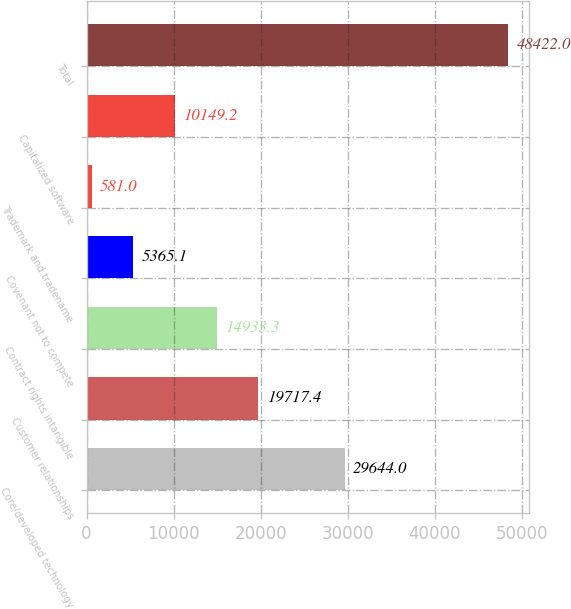Convert chart. <chart><loc_0><loc_0><loc_500><loc_500><bar_chart><fcel>Core/developed technology<fcel>Customer relationships<fcel>Contract rights intangible<fcel>Covenant not to compete<fcel>Trademark and tradename<fcel>Capitalized software<fcel>Total<nl><fcel>29644<fcel>19717.4<fcel>14933.3<fcel>5365.1<fcel>581<fcel>10149.2<fcel>48422<nl></chart> 